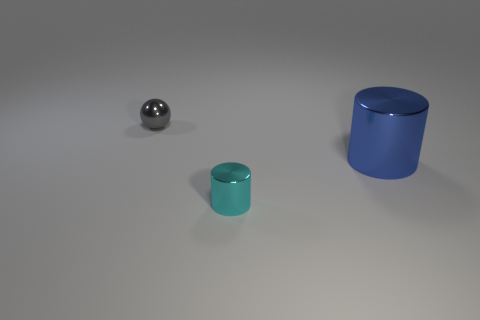There is a shiny object that is behind the large object; does it have the same shape as the blue shiny thing? The shiny object behind the larger one does not have the same shape. While both objects are shiny and reflect light, the one in front is a cylinder, and the object behind appears to be a sphere. 